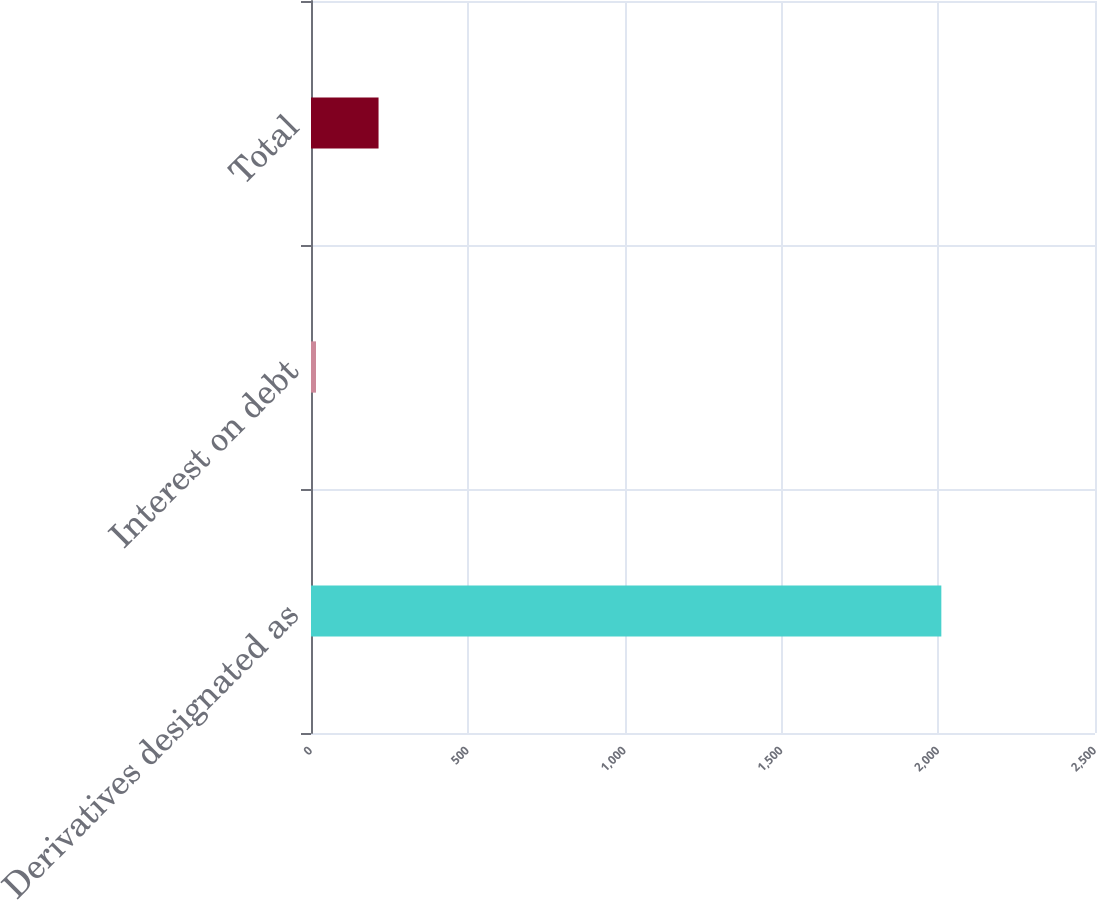Convert chart to OTSL. <chart><loc_0><loc_0><loc_500><loc_500><bar_chart><fcel>Derivatives designated as<fcel>Interest on debt<fcel>Total<nl><fcel>2010<fcel>16<fcel>215.4<nl></chart> 